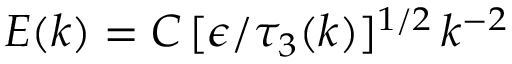<formula> <loc_0><loc_0><loc_500><loc_500>E ( k ) = C \, [ \epsilon / \tau _ { 3 } ( k ) ] ^ { 1 / 2 } \, k ^ { - 2 }</formula> 